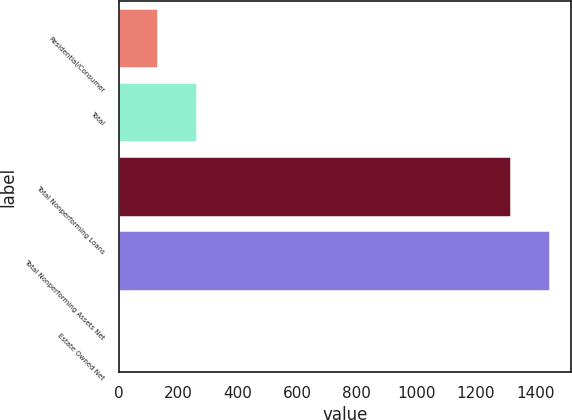Convert chart to OTSL. <chart><loc_0><loc_0><loc_500><loc_500><bar_chart><fcel>Residential/Consumer<fcel>Total<fcel>Total Nonperforming Loans<fcel>Total Nonperforming Assets Net<fcel>Estate Owned Net<nl><fcel>131.82<fcel>263.51<fcel>1317<fcel>1448.69<fcel>0.13<nl></chart> 